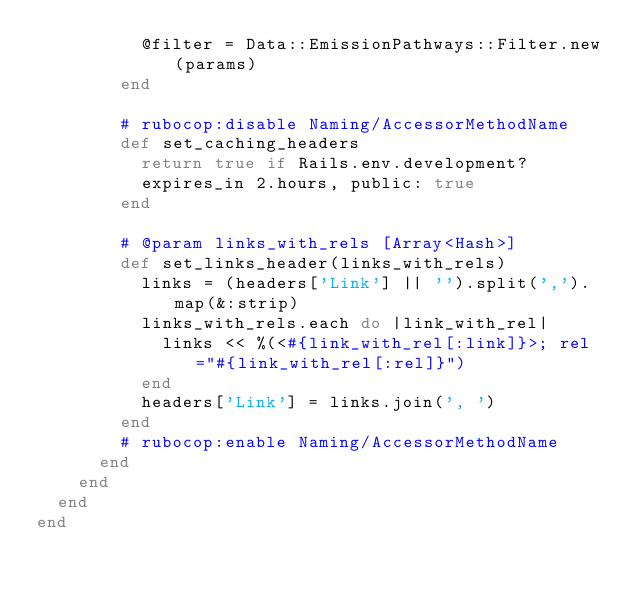Convert code to text. <code><loc_0><loc_0><loc_500><loc_500><_Ruby_>          @filter = Data::EmissionPathways::Filter.new(params)
        end

        # rubocop:disable Naming/AccessorMethodName
        def set_caching_headers
          return true if Rails.env.development?
          expires_in 2.hours, public: true
        end

        # @param links_with_rels [Array<Hash>]
        def set_links_header(links_with_rels)
          links = (headers['Link'] || '').split(',').map(&:strip)
          links_with_rels.each do |link_with_rel|
            links << %(<#{link_with_rel[:link]}>; rel="#{link_with_rel[:rel]}")
          end
          headers['Link'] = links.join(', ')
        end
        # rubocop:enable Naming/AccessorMethodName
      end
    end
  end
end
</code> 